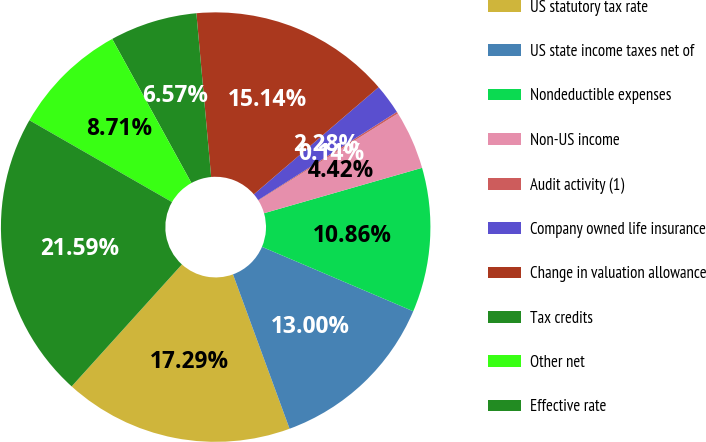Convert chart to OTSL. <chart><loc_0><loc_0><loc_500><loc_500><pie_chart><fcel>US statutory tax rate<fcel>US state income taxes net of<fcel>Nondeductible expenses<fcel>Non-US income<fcel>Audit activity (1)<fcel>Company owned life insurance<fcel>Change in valuation allowance<fcel>Tax credits<fcel>Other net<fcel>Effective rate<nl><fcel>17.29%<fcel>13.0%<fcel>10.86%<fcel>4.42%<fcel>0.14%<fcel>2.28%<fcel>15.14%<fcel>6.57%<fcel>8.71%<fcel>21.59%<nl></chart> 